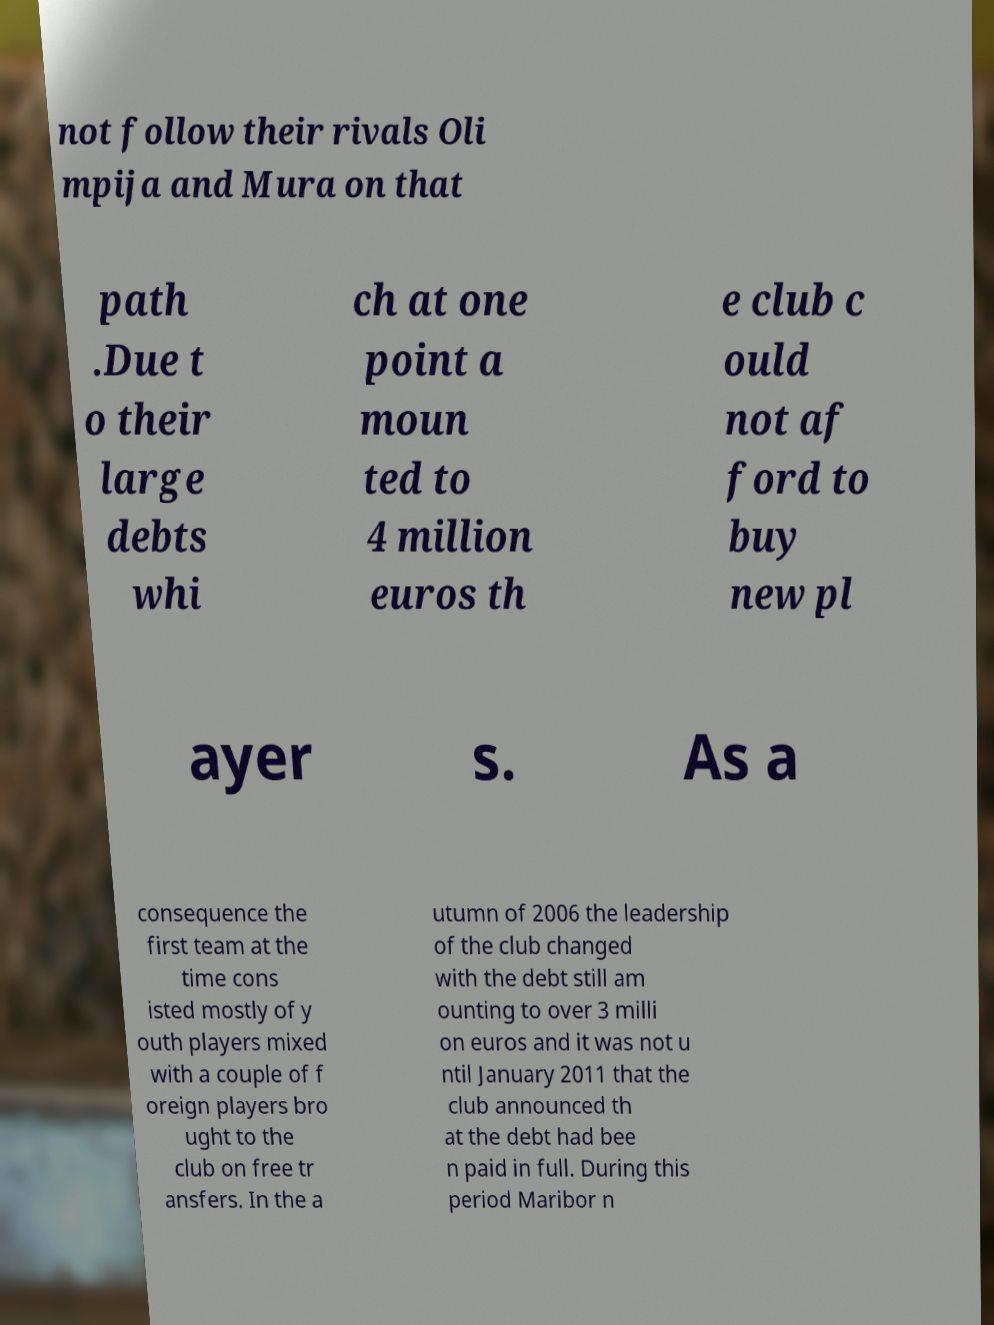Can you read and provide the text displayed in the image?This photo seems to have some interesting text. Can you extract and type it out for me? not follow their rivals Oli mpija and Mura on that path .Due t o their large debts whi ch at one point a moun ted to 4 million euros th e club c ould not af ford to buy new pl ayer s. As a consequence the first team at the time cons isted mostly of y outh players mixed with a couple of f oreign players bro ught to the club on free tr ansfers. In the a utumn of 2006 the leadership of the club changed with the debt still am ounting to over 3 milli on euros and it was not u ntil January 2011 that the club announced th at the debt had bee n paid in full. During this period Maribor n 